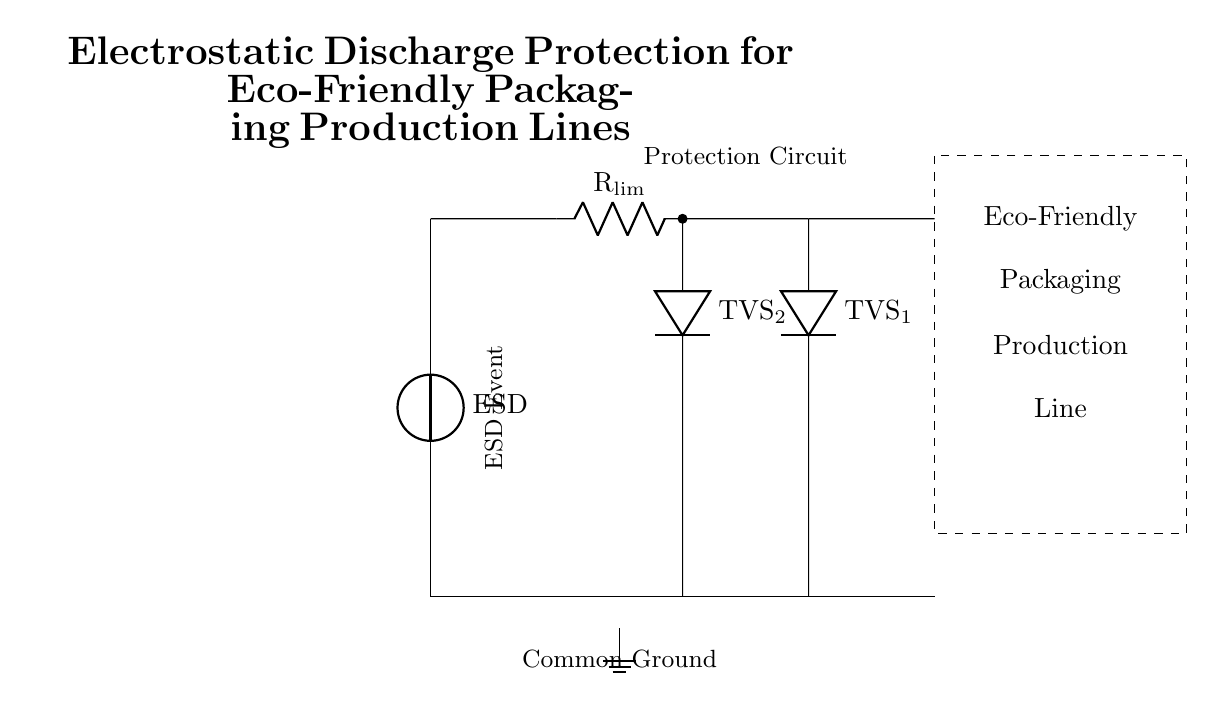What type of ESD component is used in this circuit? The circuit uses two Transient Voltage Suppressors, denoted as TVS1 and TVS2, which are specifically designed to protect against ESD.
Answer: Transient Voltage Suppressors What connects the ESD source to the protection circuit? The ESD source is connected to the protection circuit through a short wire represented by a straight line.
Answer: A short wire What is the value of the limiting resistor symbolized by Rlim? The diagram does not specify a numerical value for Rlim; however, it serves to limit the current during an ESD event. As such, the exact value can vary based on application requirements.
Answer: Not specified How many Transient Voltage Suppressors are present in the circuit? The circuit diagram shows two distinct TVS components, TVS1 and TVS2.
Answer: Two What is the role of the ground connection in this circuit? The ground connection provides a reference point for the circuit, allowing excess current from an ESD event to be safely dissipated, thus protecting the sensitive components in the production line.
Answer: To dissipate excess current What is the purpose of the limiting resistor in this ESD protection circuit? The limiting resistor, denoted as Rlim, is intended to limit the current that flows during an ESD event, thereby protecting the downstream components from damage.
Answer: To limit current What does the dashed rectangle represent in the circuit? The dashed rectangle indicates the area or boundaries of the eco-friendly packaging production line, highlighting where the ESD protection is applied.
Answer: Eco-Friendly Packaging Production Line 